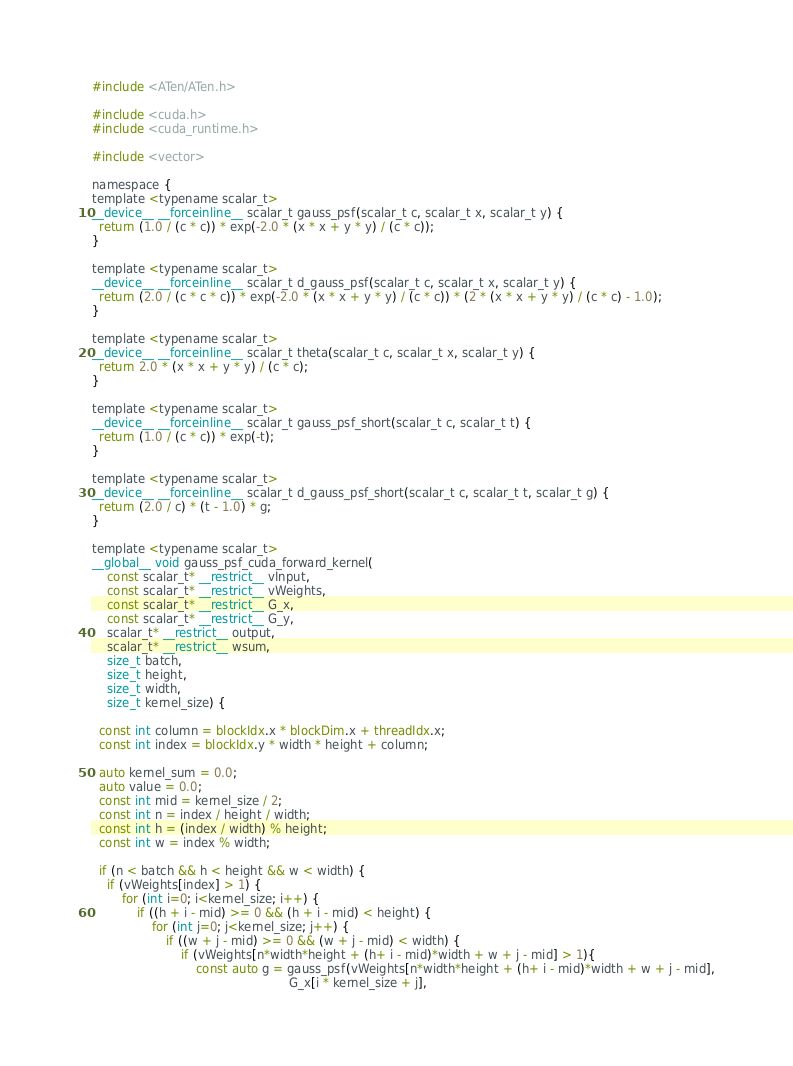Convert code to text. <code><loc_0><loc_0><loc_500><loc_500><_Cuda_>#include <ATen/ATen.h>

#include <cuda.h>
#include <cuda_runtime.h>

#include <vector>

namespace {
template <typename scalar_t>
__device__ __forceinline__ scalar_t gauss_psf(scalar_t c, scalar_t x, scalar_t y) {
  return (1.0 / (c * c)) * exp(-2.0 * (x * x + y * y) / (c * c));
}

template <typename scalar_t>
__device__ __forceinline__ scalar_t d_gauss_psf(scalar_t c, scalar_t x, scalar_t y) {
  return (2.0 / (c * c * c)) * exp(-2.0 * (x * x + y * y) / (c * c)) * (2 * (x * x + y * y) / (c * c) - 1.0);
}

template <typename scalar_t>
__device__ __forceinline__ scalar_t theta(scalar_t c, scalar_t x, scalar_t y) {
  return 2.0 * (x * x + y * y) / (c * c);
}

template <typename scalar_t>
__device__ __forceinline__ scalar_t gauss_psf_short(scalar_t c, scalar_t t) {
  return (1.0 / (c * c)) * exp(-t);
}

template <typename scalar_t>
__device__ __forceinline__ scalar_t d_gauss_psf_short(scalar_t c, scalar_t t, scalar_t g) {
  return (2.0 / c) * (t - 1.0) * g;
}

template <typename scalar_t>
__global__ void gauss_psf_cuda_forward_kernel(
    const scalar_t* __restrict__ vInput,
    const scalar_t* __restrict__ vWeights,
    const scalar_t* __restrict__ G_x,
    const scalar_t* __restrict__ G_y,
    scalar_t* __restrict__ output,
    scalar_t* __restrict__ wsum,
    size_t batch,
    size_t height,
    size_t width,
    size_t kernel_size) {

  const int column = blockIdx.x * blockDim.x + threadIdx.x;
  const int index = blockIdx.y * width * height + column;

  auto kernel_sum = 0.0;
  auto value = 0.0;
  const int mid = kernel_size / 2;
  const int n = index / height / width;
  const int h = (index / width) % height;
  const int w = index % width;

  if (n < batch && h < height && w < width) {
    if (vWeights[index] > 1) {
        for (int i=0; i<kernel_size; i++) {
            if ((h + i - mid) >= 0 && (h + i - mid) < height) {
                for (int j=0; j<kernel_size; j++) {
                    if ((w + j - mid) >= 0 && (w + j - mid) < width) {
                        if (vWeights[n*width*height + (h+ i - mid)*width + w + j - mid] > 1){
                            const auto g = gauss_psf(vWeights[n*width*height + (h+ i - mid)*width + w + j - mid],
                                                     G_x[i * kernel_size + j],</code> 